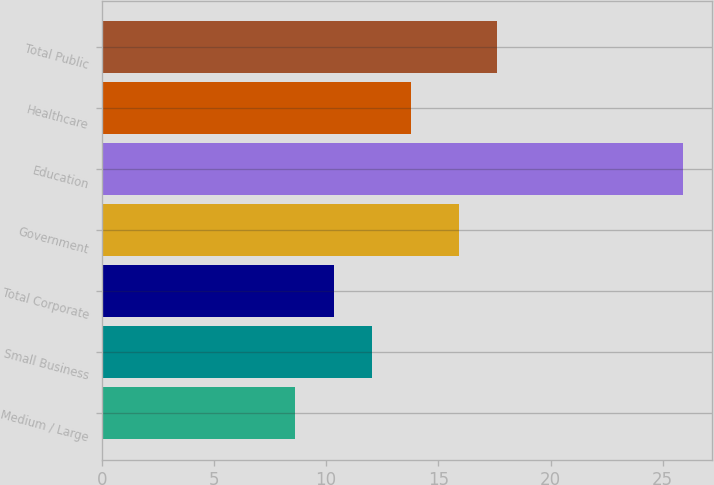<chart> <loc_0><loc_0><loc_500><loc_500><bar_chart><fcel>Medium / Large<fcel>Small Business<fcel>Total Corporate<fcel>Government<fcel>Education<fcel>Healthcare<fcel>Total Public<nl><fcel>8.6<fcel>12.06<fcel>10.33<fcel>15.9<fcel>25.9<fcel>13.79<fcel>17.63<nl></chart> 